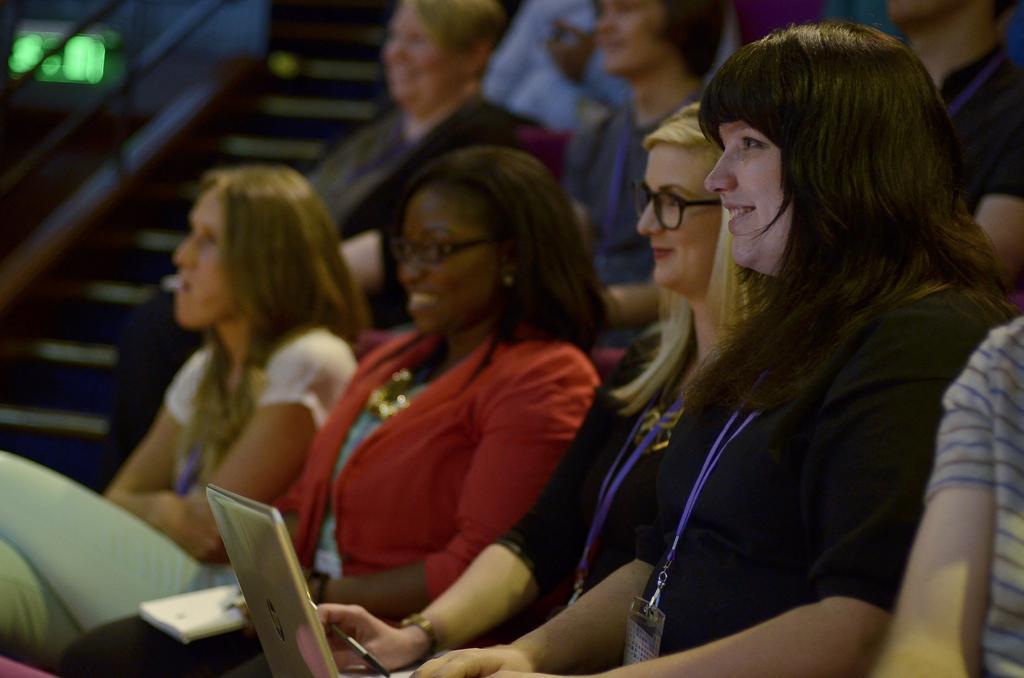Please provide a concise description of this image. In the image we can see there are people sitting on the chairs and there is laptop kept on the lap of a person. The people are wearing id cards and behind there are stairs. Background of the image is little blurred. 